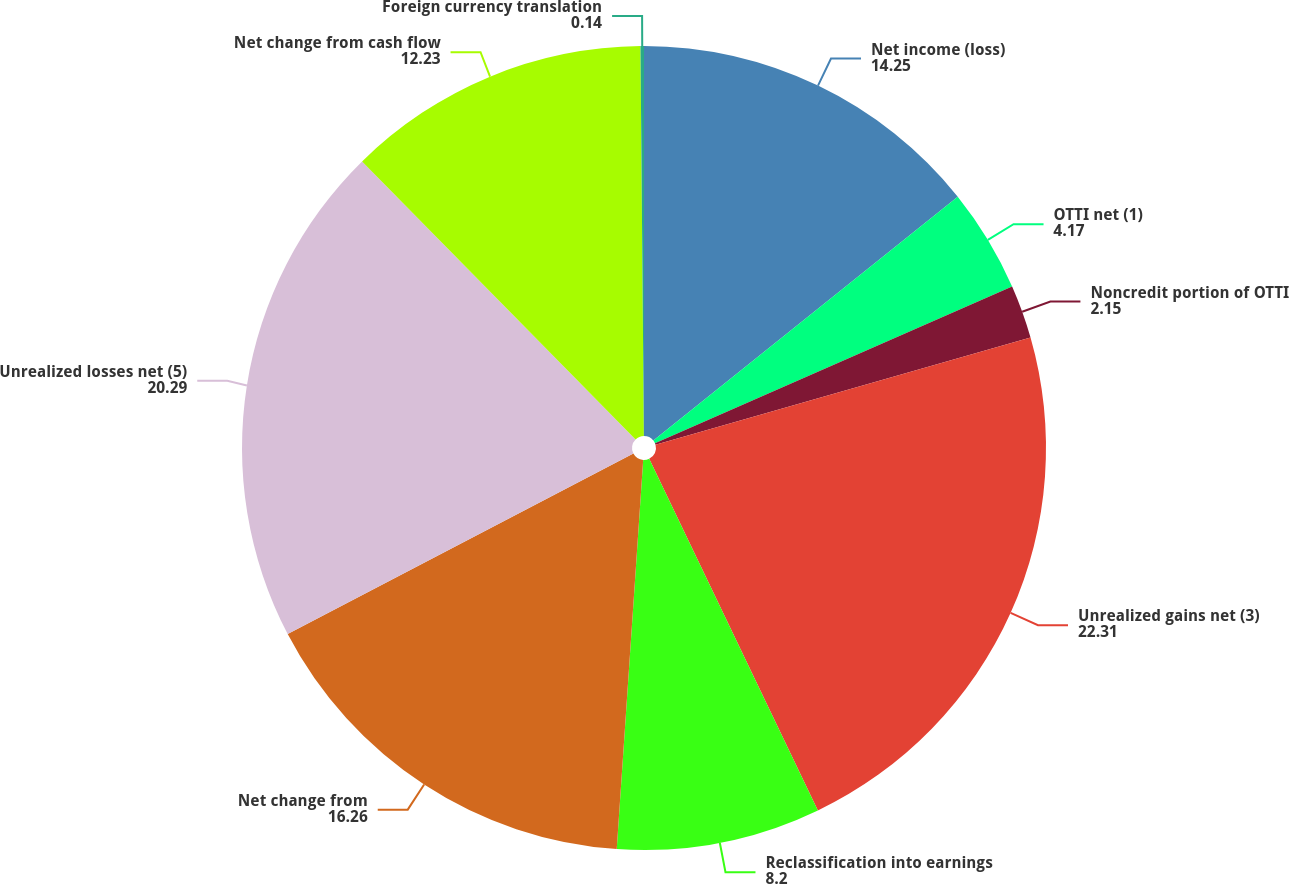Convert chart. <chart><loc_0><loc_0><loc_500><loc_500><pie_chart><fcel>Net income (loss)<fcel>OTTI net (1)<fcel>Noncredit portion of OTTI<fcel>Unrealized gains net (3)<fcel>Reclassification into earnings<fcel>Net change from<fcel>Unrealized losses net (5)<fcel>Net change from cash flow<fcel>Foreign currency translation<nl><fcel>14.25%<fcel>4.17%<fcel>2.15%<fcel>22.31%<fcel>8.2%<fcel>16.26%<fcel>20.29%<fcel>12.23%<fcel>0.14%<nl></chart> 